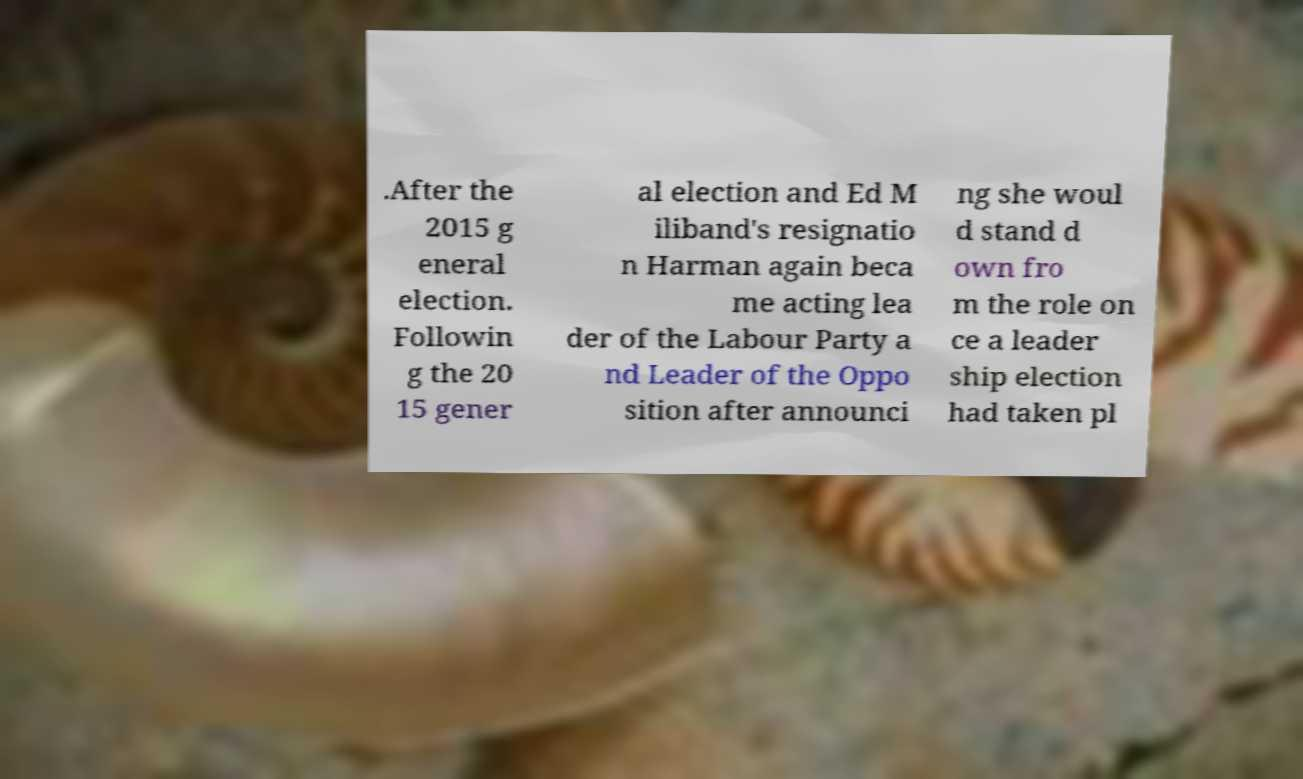Please read and relay the text visible in this image. What does it say? .After the 2015 g eneral election. Followin g the 20 15 gener al election and Ed M iliband's resignatio n Harman again beca me acting lea der of the Labour Party a nd Leader of the Oppo sition after announci ng she woul d stand d own fro m the role on ce a leader ship election had taken pl 